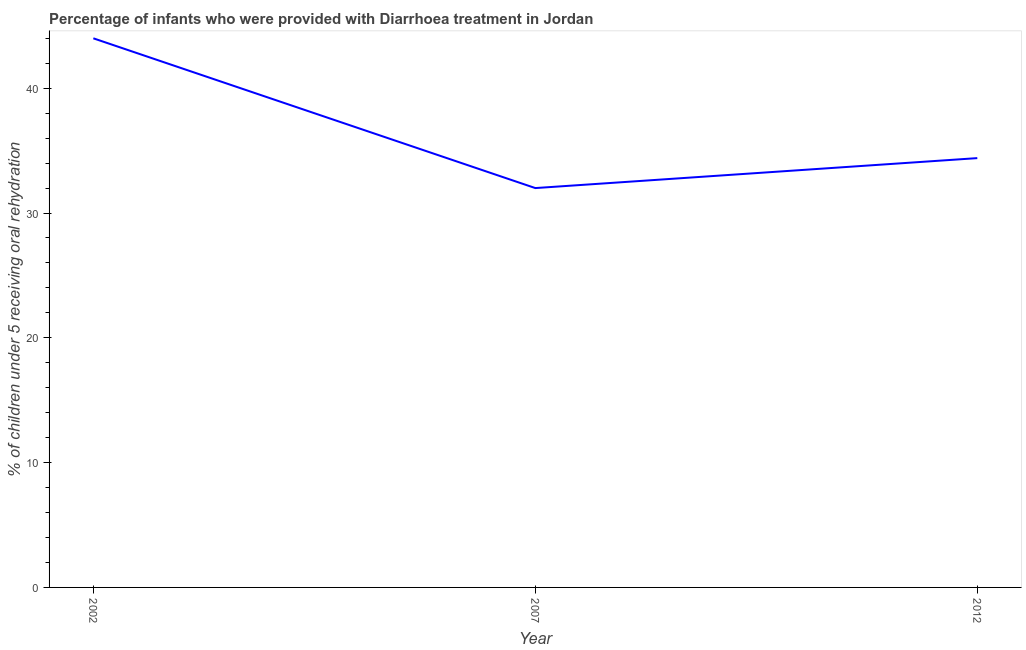Across all years, what is the minimum percentage of children who were provided with treatment diarrhoea?
Provide a short and direct response. 32. In which year was the percentage of children who were provided with treatment diarrhoea minimum?
Offer a terse response. 2007. What is the sum of the percentage of children who were provided with treatment diarrhoea?
Your answer should be very brief. 110.4. What is the difference between the percentage of children who were provided with treatment diarrhoea in 2002 and 2012?
Provide a succinct answer. 9.6. What is the average percentage of children who were provided with treatment diarrhoea per year?
Ensure brevity in your answer.  36.8. What is the median percentage of children who were provided with treatment diarrhoea?
Provide a short and direct response. 34.4. In how many years, is the percentage of children who were provided with treatment diarrhoea greater than 38 %?
Provide a succinct answer. 1. What is the ratio of the percentage of children who were provided with treatment diarrhoea in 2002 to that in 2012?
Make the answer very short. 1.28. Is the percentage of children who were provided with treatment diarrhoea in 2002 less than that in 2012?
Provide a succinct answer. No. What is the difference between the highest and the second highest percentage of children who were provided with treatment diarrhoea?
Your response must be concise. 9.6. In how many years, is the percentage of children who were provided with treatment diarrhoea greater than the average percentage of children who were provided with treatment diarrhoea taken over all years?
Your answer should be compact. 1. How many years are there in the graph?
Make the answer very short. 3. What is the difference between two consecutive major ticks on the Y-axis?
Provide a short and direct response. 10. What is the title of the graph?
Ensure brevity in your answer.  Percentage of infants who were provided with Diarrhoea treatment in Jordan. What is the label or title of the Y-axis?
Your answer should be very brief. % of children under 5 receiving oral rehydration. What is the % of children under 5 receiving oral rehydration in 2002?
Make the answer very short. 44. What is the % of children under 5 receiving oral rehydration of 2012?
Provide a succinct answer. 34.4. What is the difference between the % of children under 5 receiving oral rehydration in 2002 and 2012?
Your response must be concise. 9.6. What is the ratio of the % of children under 5 receiving oral rehydration in 2002 to that in 2007?
Provide a short and direct response. 1.38. What is the ratio of the % of children under 5 receiving oral rehydration in 2002 to that in 2012?
Give a very brief answer. 1.28. 